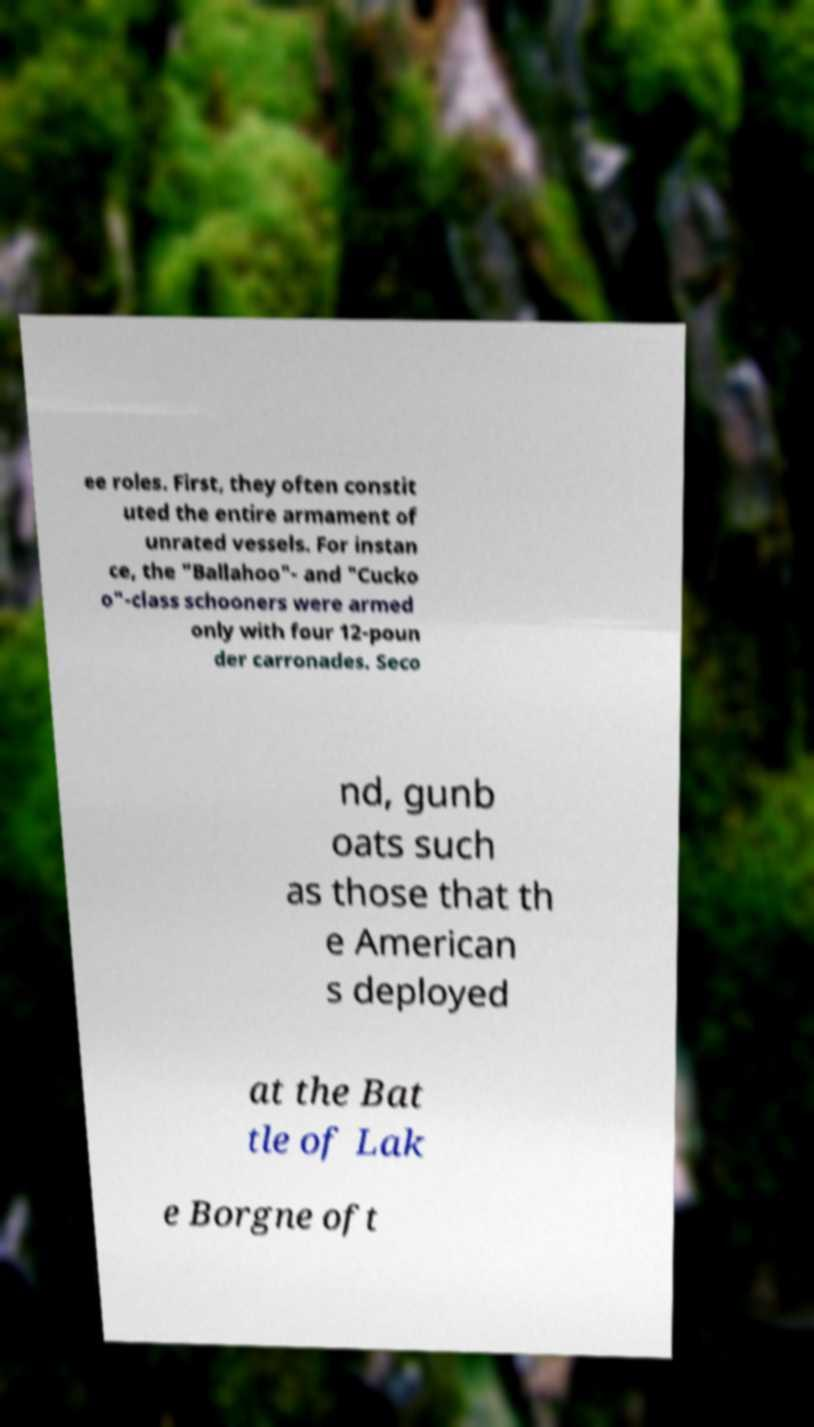Please identify and transcribe the text found in this image. ee roles. First, they often constit uted the entire armament of unrated vessels. For instan ce, the "Ballahoo"- and "Cucko o"-class schooners were armed only with four 12-poun der carronades. Seco nd, gunb oats such as those that th e American s deployed at the Bat tle of Lak e Borgne oft 